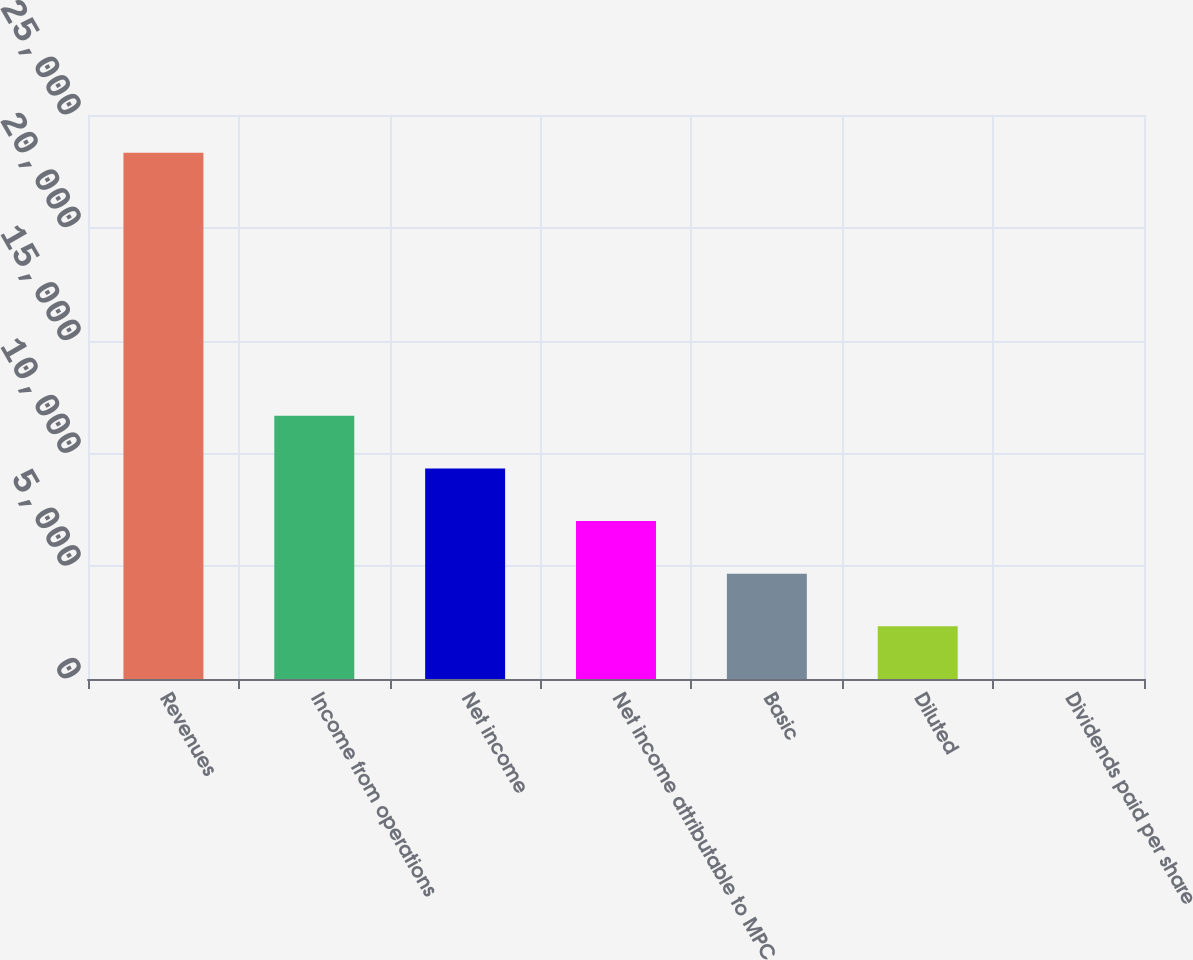<chart> <loc_0><loc_0><loc_500><loc_500><bar_chart><fcel>Revenues<fcel>Income from operations<fcel>Net income<fcel>Net income attributable to MPC<fcel>Basic<fcel>Diluted<fcel>Dividends paid per share<nl><fcel>23330<fcel>11665.2<fcel>9332.2<fcel>6999.24<fcel>4666.28<fcel>2333.32<fcel>0.35<nl></chart> 